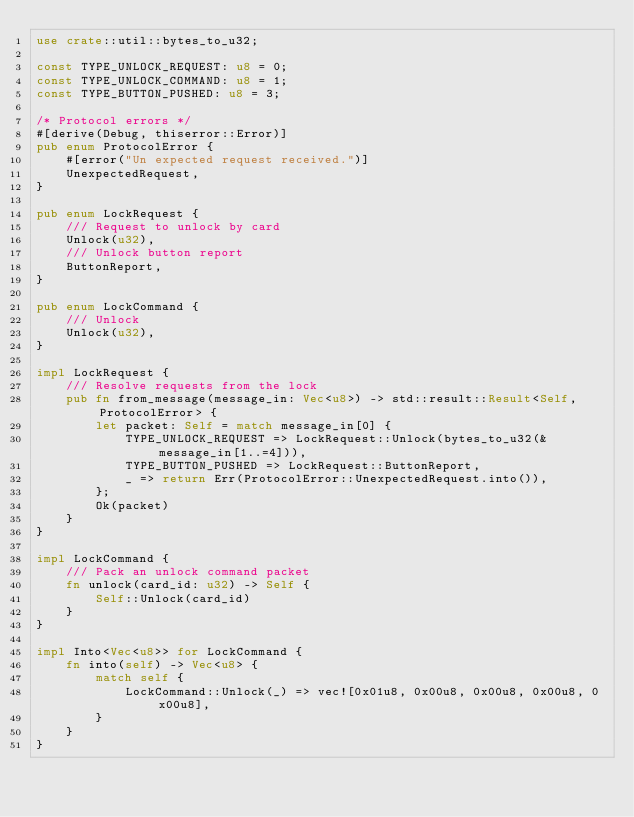<code> <loc_0><loc_0><loc_500><loc_500><_Rust_>use crate::util::bytes_to_u32;

const TYPE_UNLOCK_REQUEST: u8 = 0;
const TYPE_UNLOCK_COMMAND: u8 = 1;
const TYPE_BUTTON_PUSHED: u8 = 3;

/* Protocol errors */
#[derive(Debug, thiserror::Error)]
pub enum ProtocolError {
    #[error("Un expected request received.")]
    UnexpectedRequest,
}

pub enum LockRequest {
    /// Request to unlock by card
    Unlock(u32),
    /// Unlock button report
    ButtonReport,
}

pub enum LockCommand {
    /// Unlock
    Unlock(u32),
}

impl LockRequest {
    /// Resolve requests from the lock
    pub fn from_message(message_in: Vec<u8>) -> std::result::Result<Self, ProtocolError> {
        let packet: Self = match message_in[0] {
            TYPE_UNLOCK_REQUEST => LockRequest::Unlock(bytes_to_u32(&message_in[1..=4])),
            TYPE_BUTTON_PUSHED => LockRequest::ButtonReport,
            _ => return Err(ProtocolError::UnexpectedRequest.into()),
        };
        Ok(packet)
    }
}

impl LockCommand {
    /// Pack an unlock command packet
    fn unlock(card_id: u32) -> Self {
        Self::Unlock(card_id)
    }
}

impl Into<Vec<u8>> for LockCommand {
    fn into(self) -> Vec<u8> {
        match self {
            LockCommand::Unlock(_) => vec![0x01u8, 0x00u8, 0x00u8, 0x00u8, 0x00u8],
        }
    }
}
</code> 